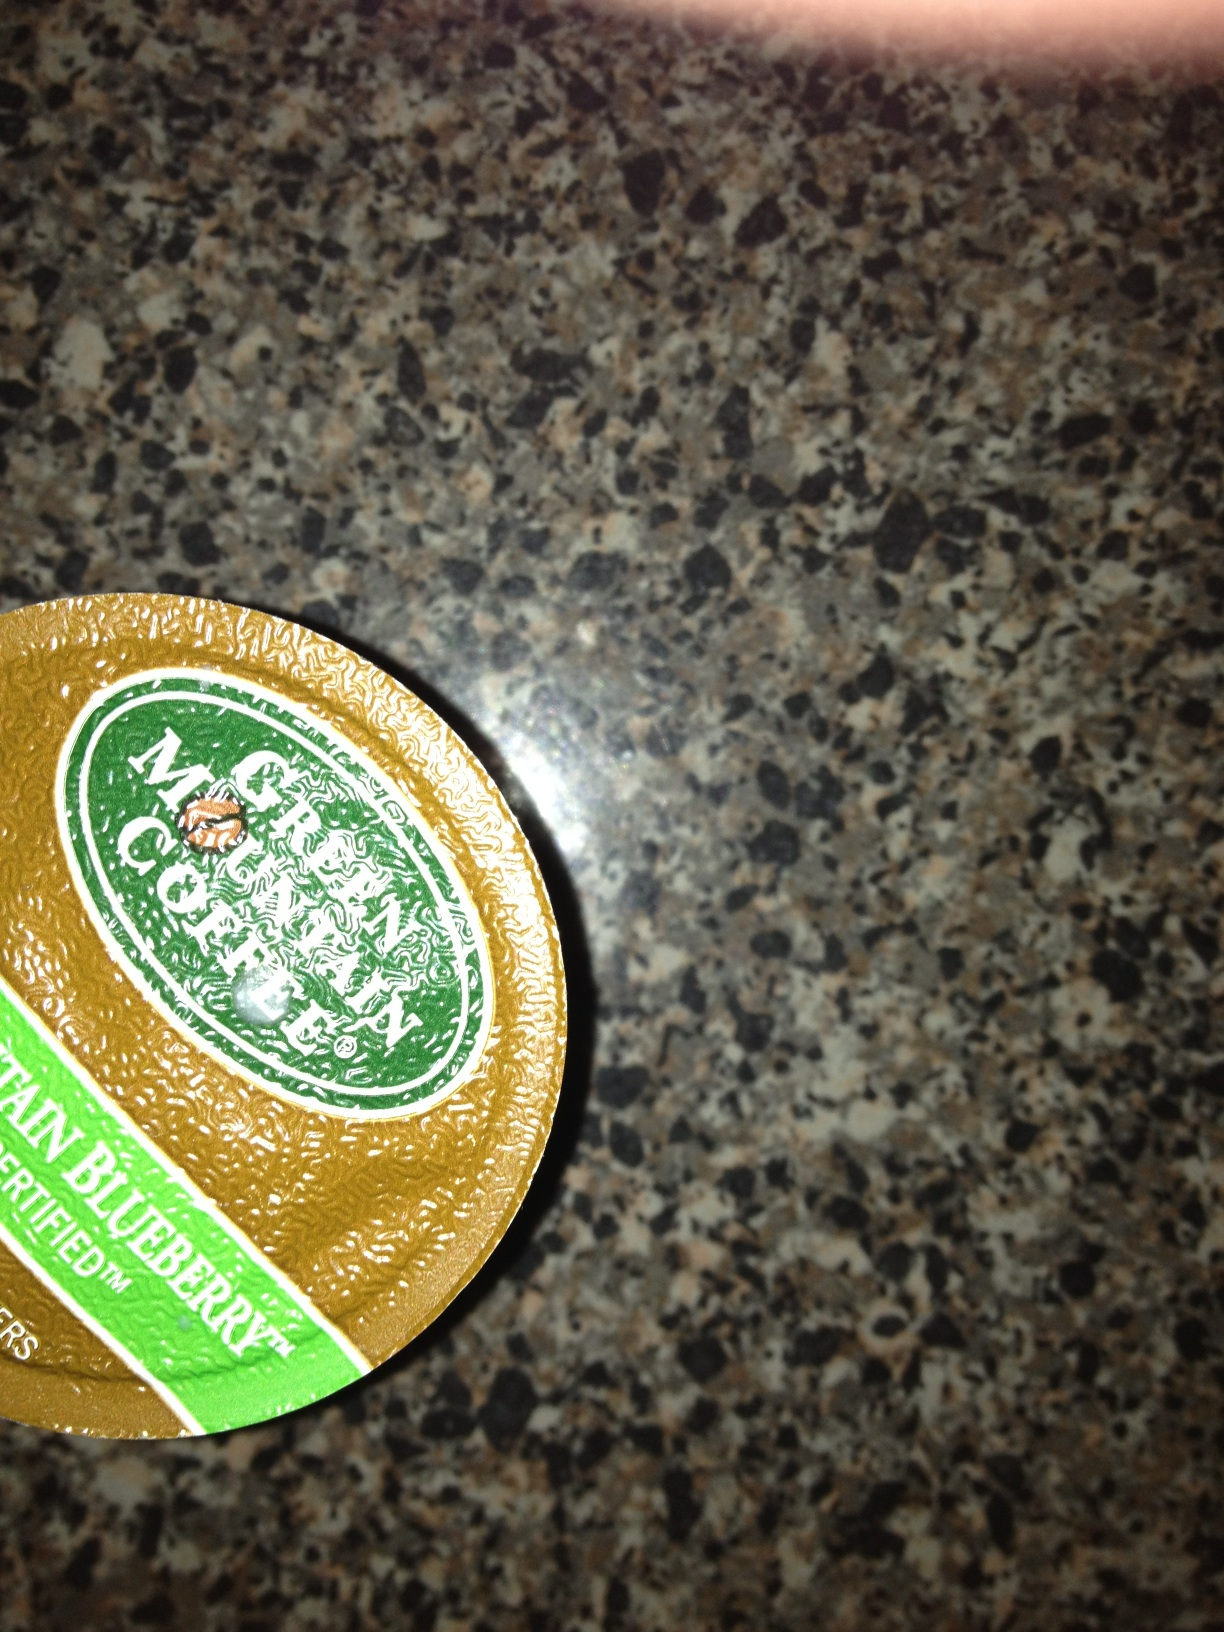What kind of coffee is this? This is a Green Mountain Coffee Roasters product, specifically the Mountain Blueberry flavor. It's a unique and refreshing coffee option known for its fruity blueberry notes combined with a smooth overall flavor profile. 